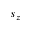<formula> <loc_0><loc_0><loc_500><loc_500>s _ { z }</formula> 